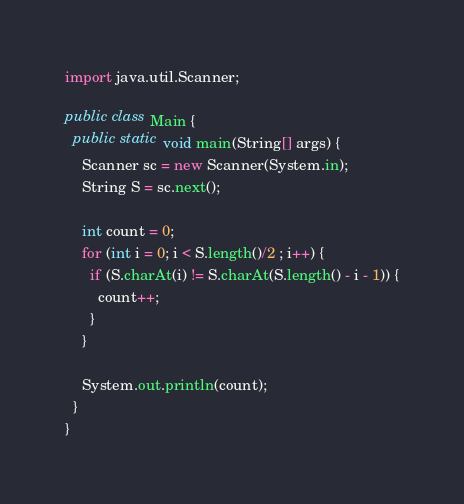<code> <loc_0><loc_0><loc_500><loc_500><_Java_>import java.util.Scanner;

public class Main {
  public static void main(String[] args) {
    Scanner sc = new Scanner(System.in);
    String S = sc.next();

    int count = 0;
    for (int i = 0; i < S.length()/2 ; i++) {
      if (S.charAt(i) != S.charAt(S.length() - i - 1)) {
        count++;
      }
    }

    System.out.println(count);
  }
}
</code> 